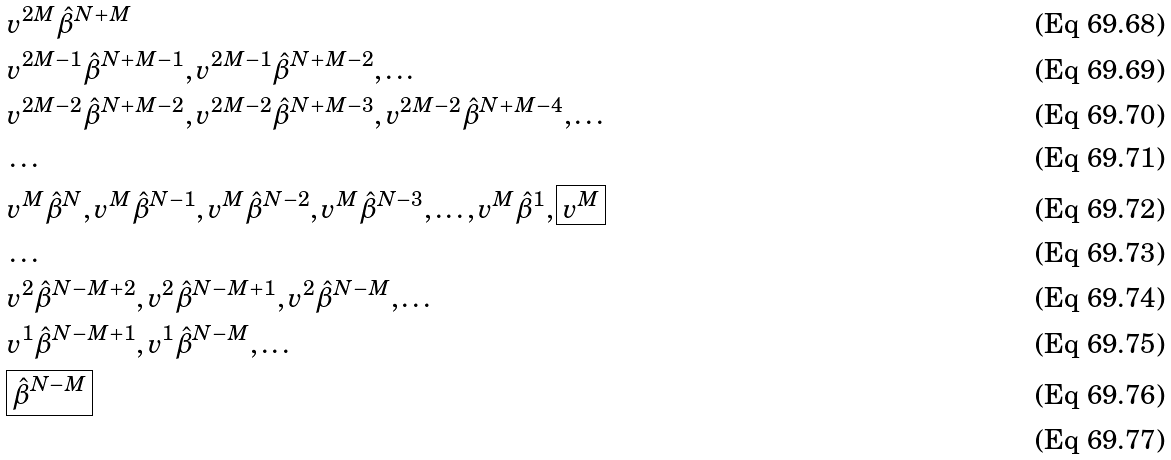Convert formula to latex. <formula><loc_0><loc_0><loc_500><loc_500>& v ^ { 2 M } \hat { \beta } ^ { N + M } \\ & v ^ { 2 M - 1 } \hat { \beta } ^ { N + M - 1 } , v ^ { 2 M - 1 } \hat { \beta } ^ { N + M - 2 } , \dots \\ & v ^ { 2 M - 2 } \hat { \beta } ^ { N + M - 2 } , v ^ { 2 M - 2 } \hat { \beta } ^ { N + M - 3 } , v ^ { 2 M - 2 } \hat { \beta } ^ { N + M - 4 } , \dots \\ & \dots \\ & v ^ { M } \hat { \beta } ^ { N } , v ^ { M } \hat { \beta } ^ { N - 1 } , v ^ { M } \hat { \beta } ^ { N - 2 } , v ^ { M } \hat { \beta } ^ { N - 3 } , \dots , v ^ { M } \hat { \beta } ^ { 1 } , \boxed { v ^ { M } } \\ & \dots \\ & v ^ { 2 } \hat { \beta } ^ { N - M + 2 } , v ^ { 2 } \hat { \beta } ^ { N - M + 1 } , v ^ { 2 } \hat { \beta } ^ { N - M } , \dots \\ & v ^ { 1 } \hat { \beta } ^ { N - M + 1 } , v ^ { 1 } \hat { \beta } ^ { N - M } , \dots \\ & \boxed { \hat { \beta } ^ { N - M } } \\</formula> 